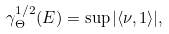Convert formula to latex. <formula><loc_0><loc_0><loc_500><loc_500>\gamma _ { \Theta } ^ { 1 / 2 } ( E ) = \sup | \langle \nu , 1 \rangle | ,</formula> 